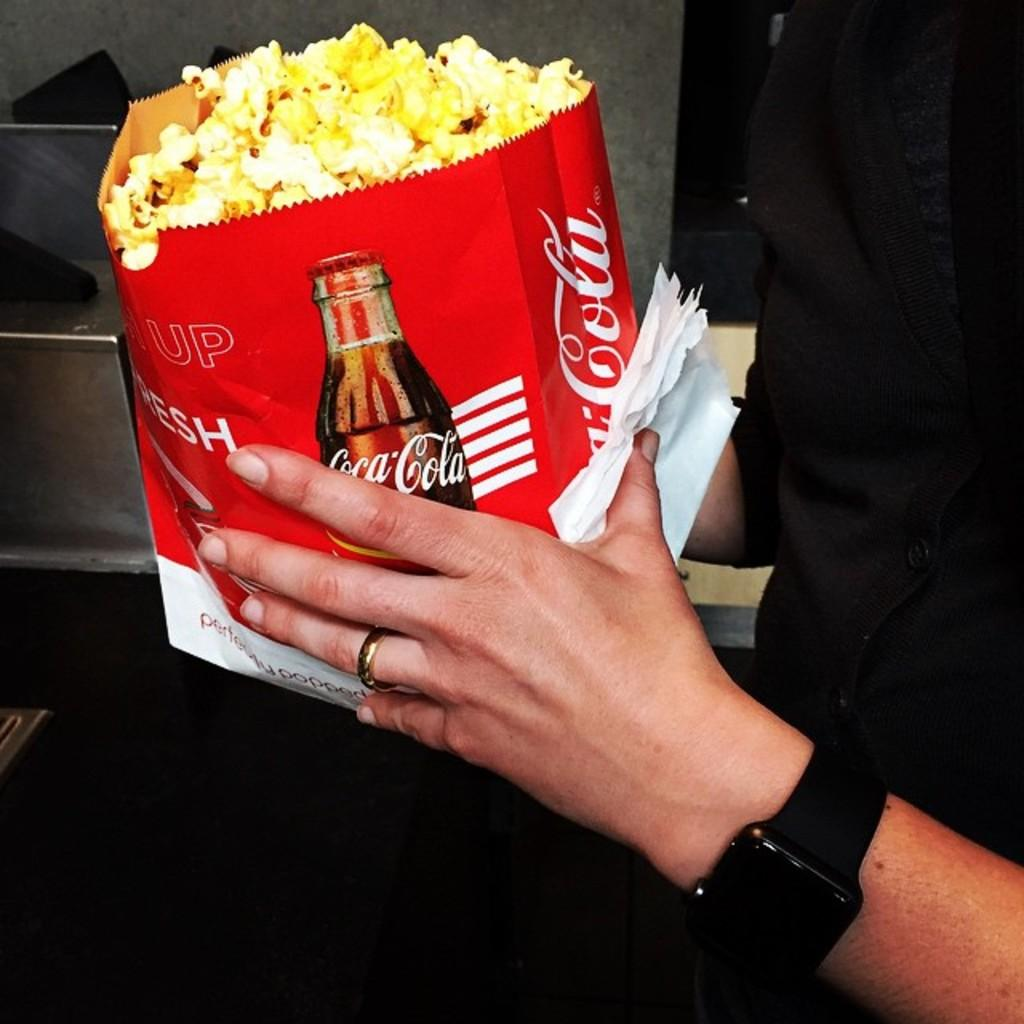<image>
Provide a brief description of the given image. A bag of popcorn says "Coca Cola" on the side. 